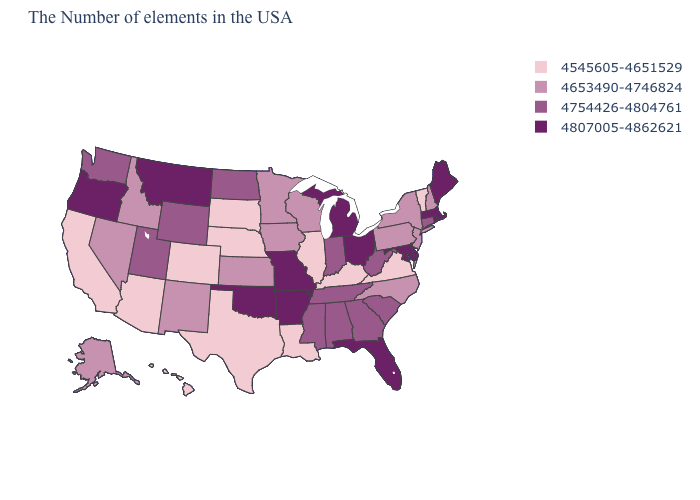Does Ohio have the same value as Iowa?
Short answer required. No. Name the states that have a value in the range 4545605-4651529?
Concise answer only. Vermont, Virginia, Kentucky, Illinois, Louisiana, Nebraska, Texas, South Dakota, Colorado, Arizona, California, Hawaii. How many symbols are there in the legend?
Short answer required. 4. What is the highest value in the MidWest ?
Be succinct. 4807005-4862621. Name the states that have a value in the range 4807005-4862621?
Write a very short answer. Maine, Massachusetts, Rhode Island, Delaware, Maryland, Ohio, Florida, Michigan, Missouri, Arkansas, Oklahoma, Montana, Oregon. Does Connecticut have a lower value than Nevada?
Quick response, please. No. Does Virginia have the lowest value in the South?
Quick response, please. Yes. What is the lowest value in states that border Minnesota?
Concise answer only. 4545605-4651529. Which states have the lowest value in the USA?
Quick response, please. Vermont, Virginia, Kentucky, Illinois, Louisiana, Nebraska, Texas, South Dakota, Colorado, Arizona, California, Hawaii. What is the highest value in states that border South Dakota?
Give a very brief answer. 4807005-4862621. Among the states that border Utah , does Wyoming have the lowest value?
Short answer required. No. What is the lowest value in the USA?
Concise answer only. 4545605-4651529. Name the states that have a value in the range 4653490-4746824?
Answer briefly. New Hampshire, New York, New Jersey, Pennsylvania, North Carolina, Wisconsin, Minnesota, Iowa, Kansas, New Mexico, Idaho, Nevada, Alaska. Does the first symbol in the legend represent the smallest category?
Short answer required. Yes. 